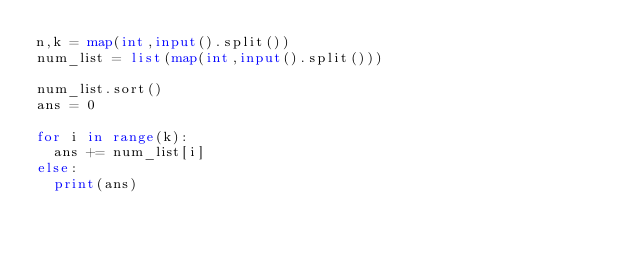<code> <loc_0><loc_0><loc_500><loc_500><_Python_>n,k = map(int,input().split())
num_list = list(map(int,input().split()))

num_list.sort()
ans = 0

for i in range(k):
  ans += num_list[i]
else:
  print(ans)
</code> 